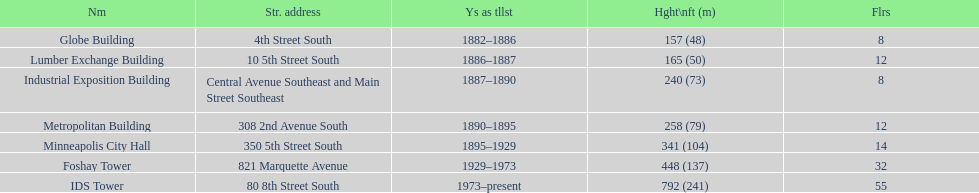Name the tallest building. IDS Tower. 